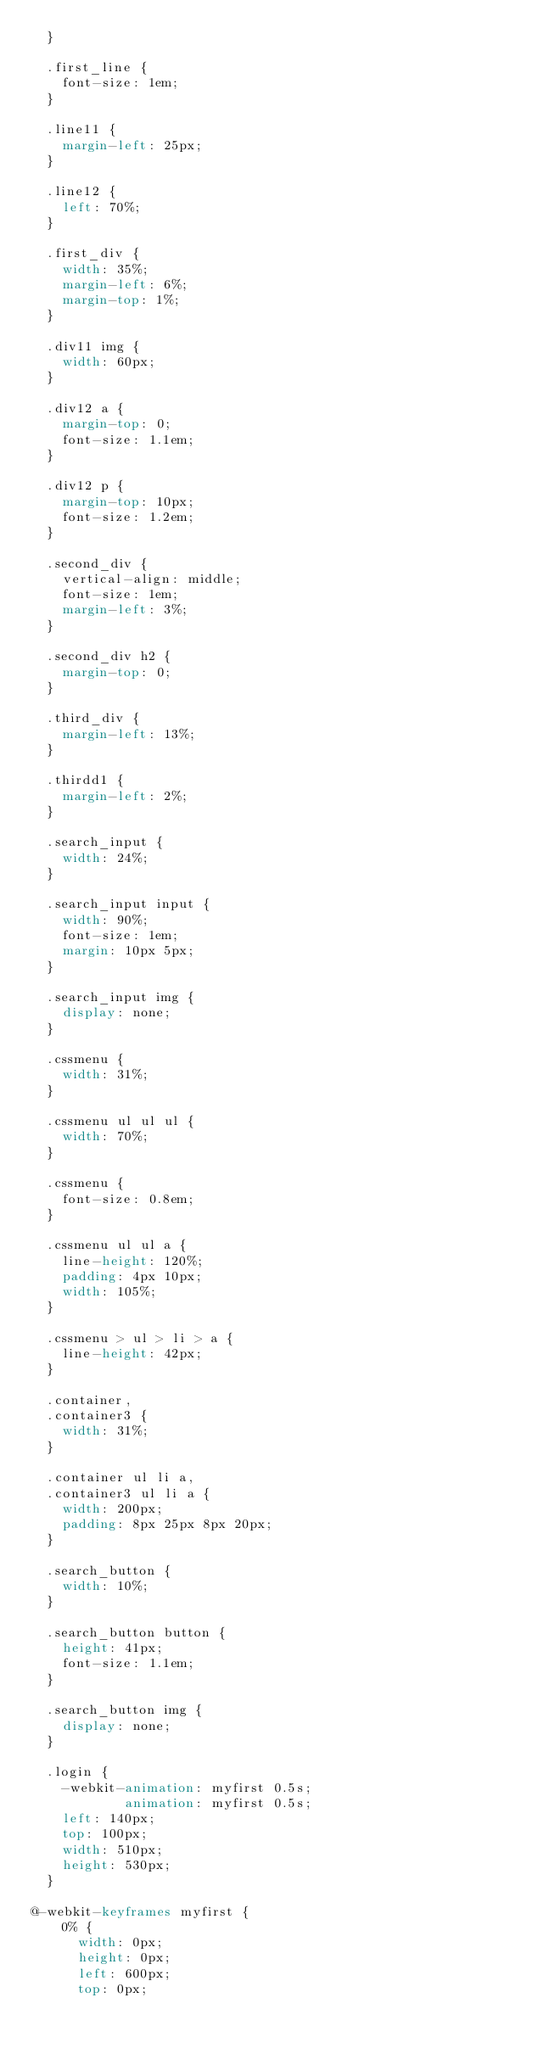Convert code to text. <code><loc_0><loc_0><loc_500><loc_500><_CSS_>  }

  .first_line {
    font-size: 1em;
  }

  .line11 {
    margin-left: 25px;
  }

  .line12 {
    left: 70%;
  }

  .first_div {
    width: 35%;
    margin-left: 6%;
    margin-top: 1%;
  }

  .div11 img {
    width: 60px;
  }

  .div12 a {
    margin-top: 0;
    font-size: 1.1em;
  }

  .div12 p {
    margin-top: 10px;
    font-size: 1.2em;
  }

  .second_div {
    vertical-align: middle;
    font-size: 1em;
    margin-left: 3%;
  }

  .second_div h2 {
    margin-top: 0;
  }

  .third_div {
    margin-left: 13%;
  }

  .thirdd1 {
    margin-left: 2%;
  }

  .search_input {
    width: 24%;
  }

  .search_input input {
    width: 90%;
    font-size: 1em;
    margin: 10px 5px;
  }

  .search_input img {
    display: none;
  }

  .cssmenu {
    width: 31%;
  }

  .cssmenu ul ul ul {
    width: 70%;
  }

  .cssmenu {
    font-size: 0.8em;
  }

  .cssmenu ul ul a {
    line-height: 120%;
    padding: 4px 10px;
    width: 105%;
  }

  .cssmenu > ul > li > a {
    line-height: 42px;
  }

  .container,
  .container3 {
    width: 31%;
  }

  .container ul li a,
  .container3 ul li a {
    width: 200px;
    padding: 8px 25px 8px 20px;
  }

  .search_button {
    width: 10%;
  }

  .search_button button {
    height: 41px;
    font-size: 1.1em;
  }

  .search_button img {
    display: none;
  }

  .login {
    -webkit-animation: myfirst 0.5s;
            animation: myfirst 0.5s;
    left: 140px;
    top: 100px;
    width: 510px;
    height: 530px;
  }

@-webkit-keyframes myfirst {
    0% {
      width: 0px;
      height: 0px;
      left: 600px;
      top: 0px;</code> 